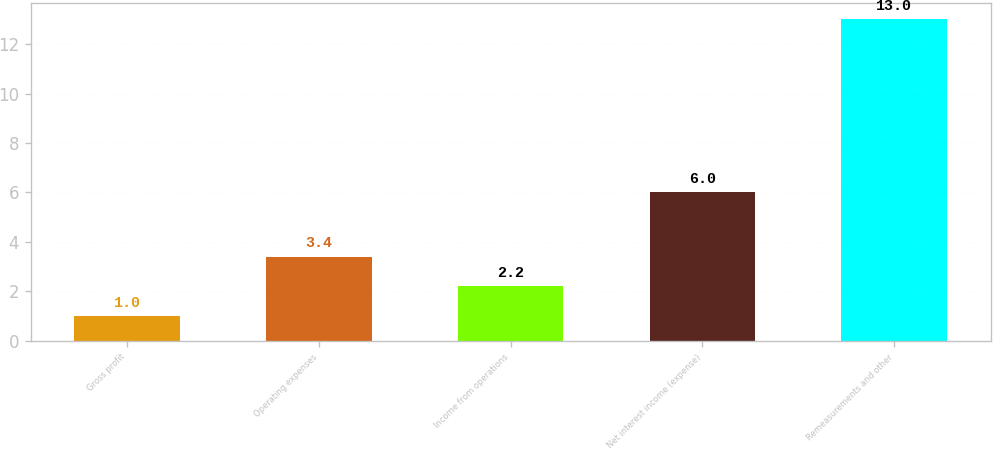Convert chart. <chart><loc_0><loc_0><loc_500><loc_500><bar_chart><fcel>Gross profit<fcel>Operating expenses<fcel>Income from operations<fcel>Net interest income (expense)<fcel>Remeasurements and other<nl><fcel>1<fcel>3.4<fcel>2.2<fcel>6<fcel>13<nl></chart> 